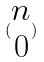Convert formula to latex. <formula><loc_0><loc_0><loc_500><loc_500>( \begin{matrix} n \\ 0 \end{matrix} )</formula> 